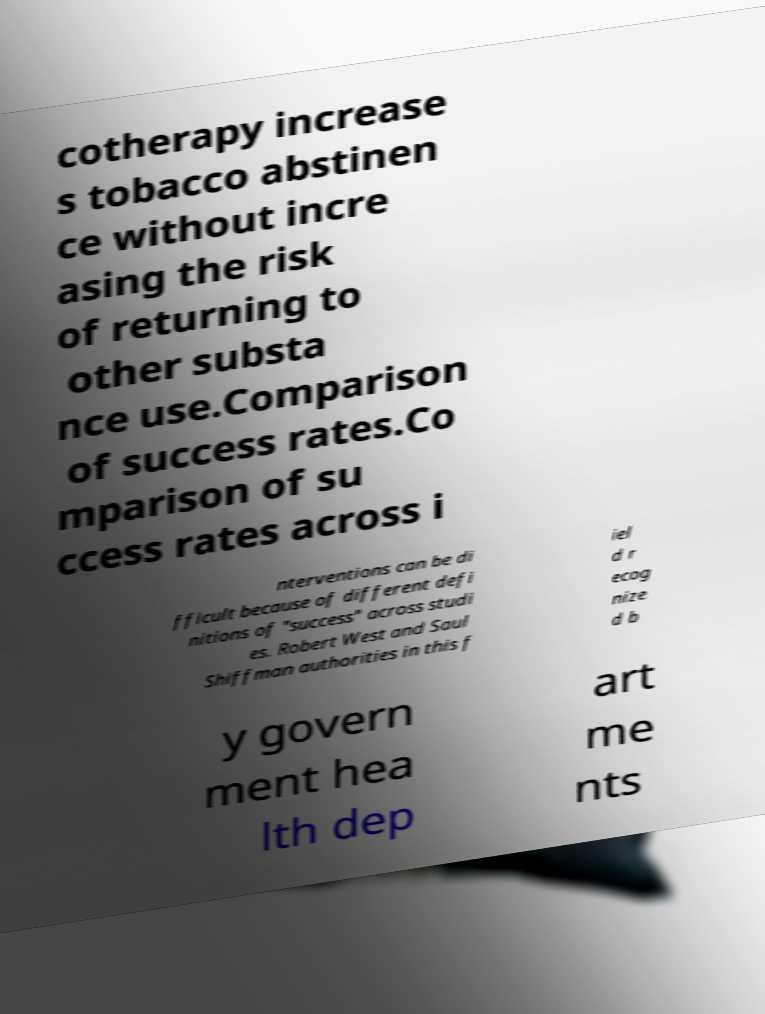Could you extract and type out the text from this image? cotherapy increase s tobacco abstinen ce without incre asing the risk of returning to other substa nce use.Comparison of success rates.Co mparison of su ccess rates across i nterventions can be di fficult because of different defi nitions of "success" across studi es. Robert West and Saul Shiffman authorities in this f iel d r ecog nize d b y govern ment hea lth dep art me nts 